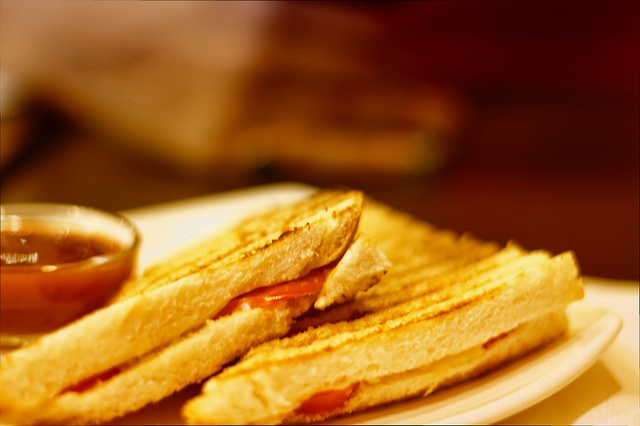Describe the objects in this image and their specific colors. I can see people in salmon, maroon, brown, and tan tones, sandwich in salmon, orange, and gold tones, sandwich in salmon, orange, gold, red, and maroon tones, and bowl in salmon, maroon, red, and orange tones in this image. 